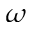Convert formula to latex. <formula><loc_0><loc_0><loc_500><loc_500>\omega</formula> 